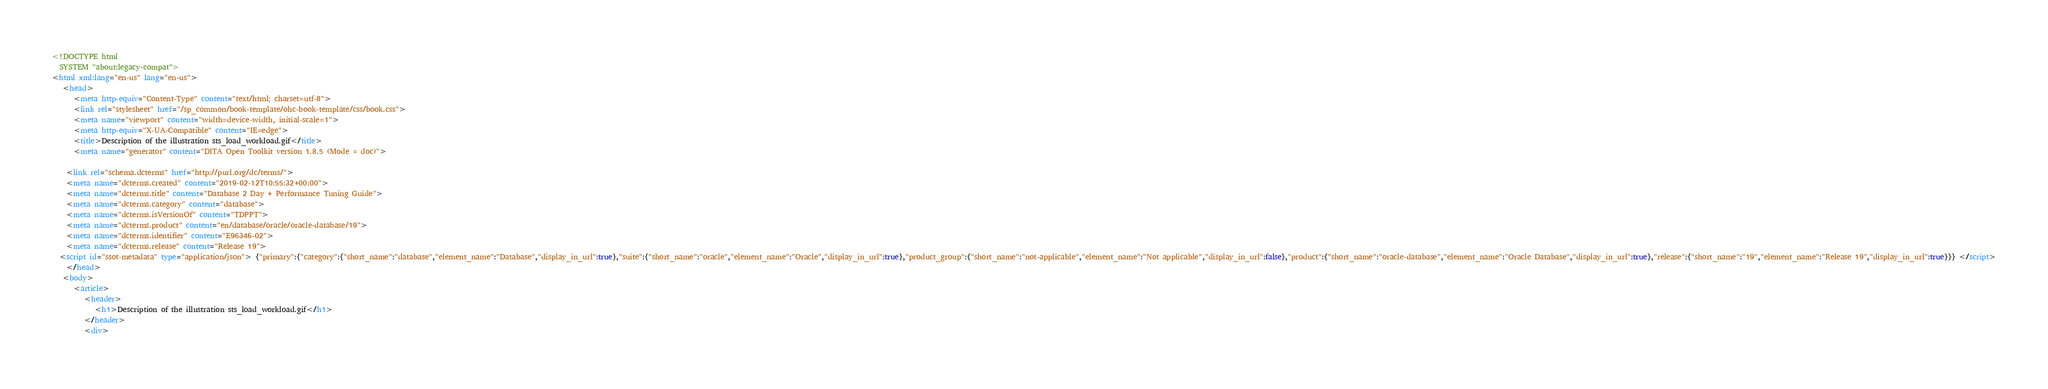<code> <loc_0><loc_0><loc_500><loc_500><_HTML_><!DOCTYPE html
  SYSTEM "about:legacy-compat">
<html xml:lang="en-us" lang="en-us">
   <head>
      <meta http-equiv="Content-Type" content="text/html; charset=utf-8">
      <link rel="stylesheet" href="/sp_common/book-template/ohc-book-template/css/book.css">
      <meta name="viewport" content="width=device-width, initial-scale=1">
      <meta http-equiv="X-UA-Compatible" content="IE=edge">
      <title>Description of the illustration sts_load_workload.gif</title>
      <meta name="generator" content="DITA Open Toolkit version 1.8.5 (Mode = doc)">
   
    <link rel="schema.dcterms" href="http://purl.org/dc/terms/">
    <meta name="dcterms.created" content="2019-02-12T10:55:32+00:00">
    <meta name="dcterms.title" content="Database 2 Day + Performance Tuning Guide">
    <meta name="dcterms.category" content="database">
    <meta name="dcterms.isVersionOf" content="TDPPT">
    <meta name="dcterms.product" content="en/database/oracle/oracle-database/19">
    <meta name="dcterms.identifier" content="E96346-02">
    <meta name="dcterms.release" content="Release 19">
  <script id="ssot-metadata" type="application/json"> {"primary":{"category":{"short_name":"database","element_name":"Database","display_in_url":true},"suite":{"short_name":"oracle","element_name":"Oracle","display_in_url":true},"product_group":{"short_name":"not-applicable","element_name":"Not applicable","display_in_url":false},"product":{"short_name":"oracle-database","element_name":"Oracle Database","display_in_url":true},"release":{"short_name":"19","element_name":"Release 19","display_in_url":true}}} </script>
    </head>
   <body>
      <article>
         <header>
            <h1>Description of the illustration sts_load_workload.gif</h1>
         </header>
         <div></code> 